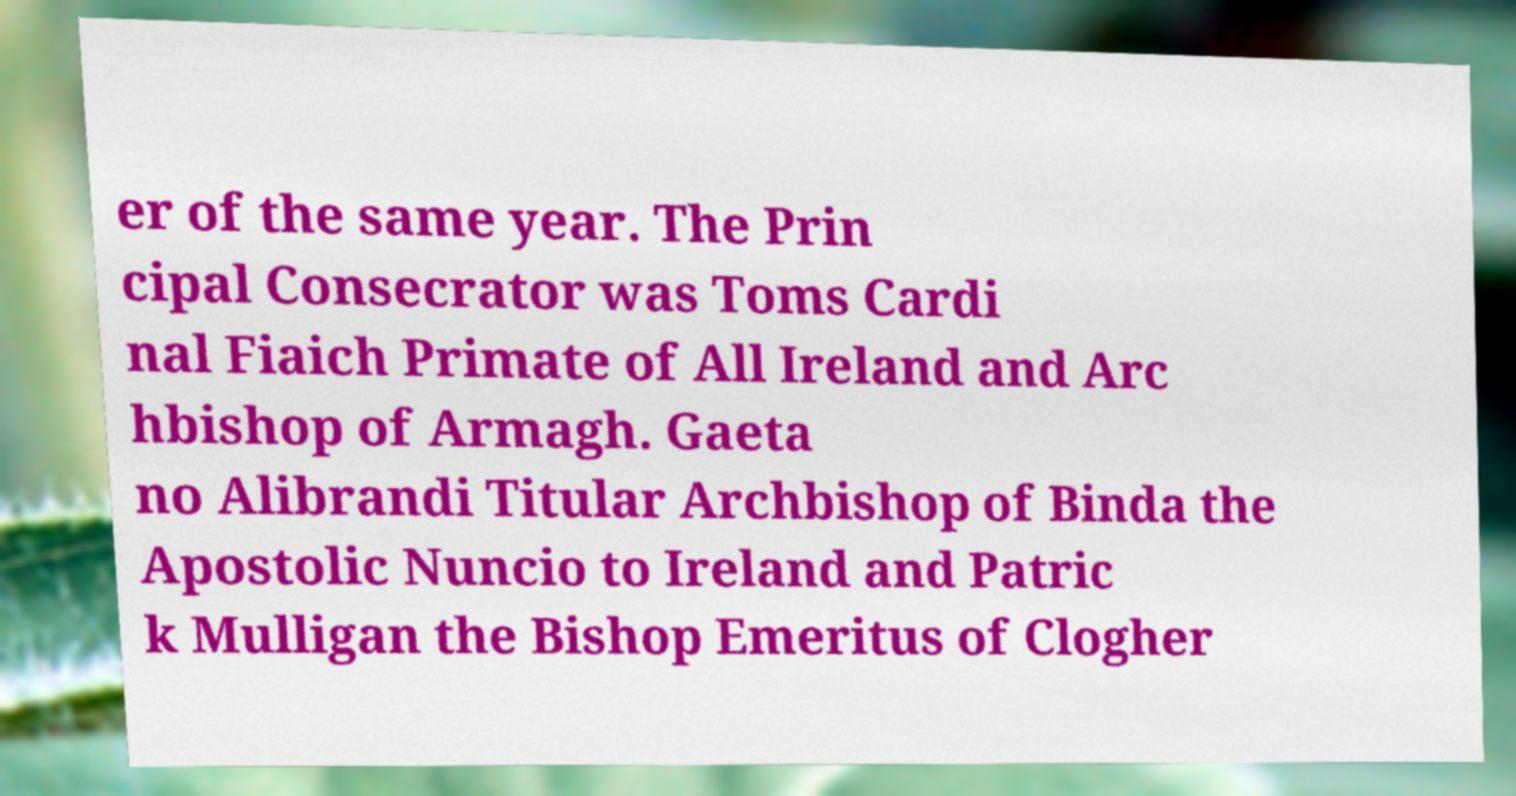Please read and relay the text visible in this image. What does it say? er of the same year. The Prin cipal Consecrator was Toms Cardi nal Fiaich Primate of All Ireland and Arc hbishop of Armagh. Gaeta no Alibrandi Titular Archbishop of Binda the Apostolic Nuncio to Ireland and Patric k Mulligan the Bishop Emeritus of Clogher 